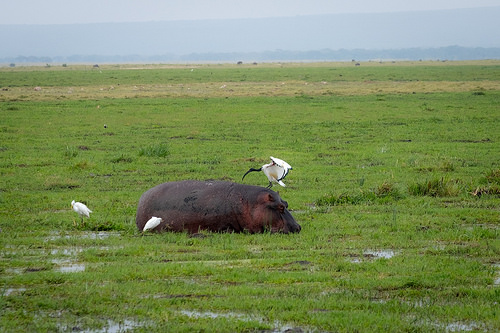<image>
Is the bird in the puddle? No. The bird is not contained within the puddle. These objects have a different spatial relationship. 